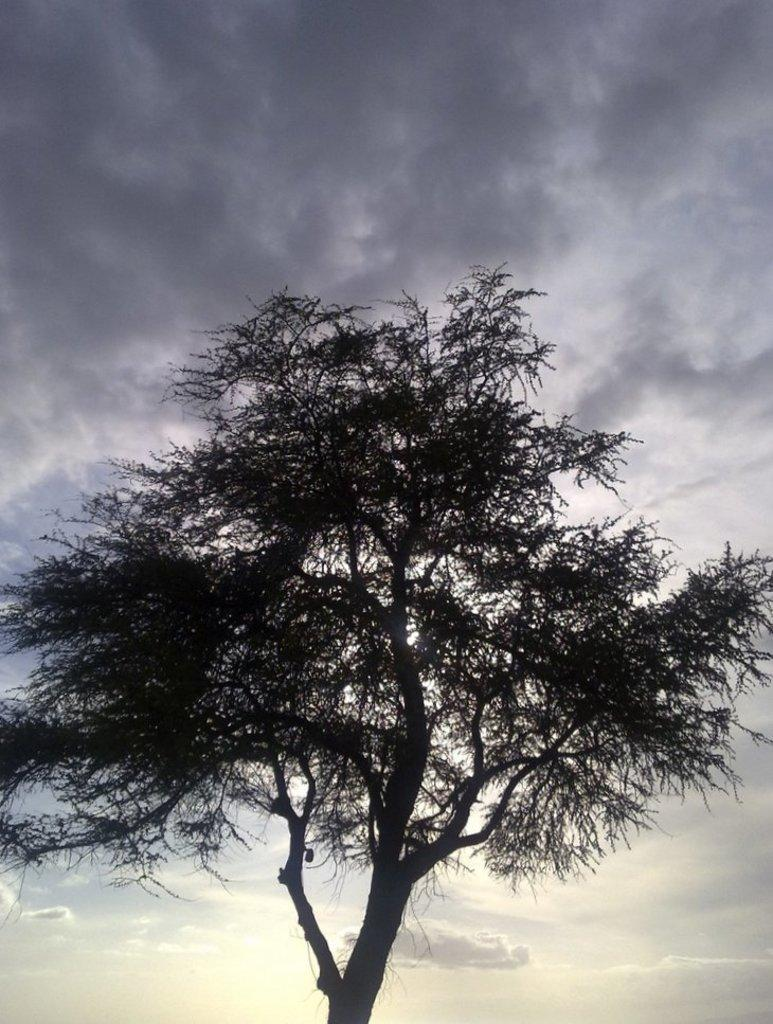What is located in the foreground of the picture? There is a tree in the foreground of the picture. What can be seen in the background of the picture? The sky is visible in the background of the picture. How would you describe the sky in the image? The sky is cloudy. How many grapes are hanging from the tree in the image? There are no grapes visible in the image; the tree does not have any fruit. 